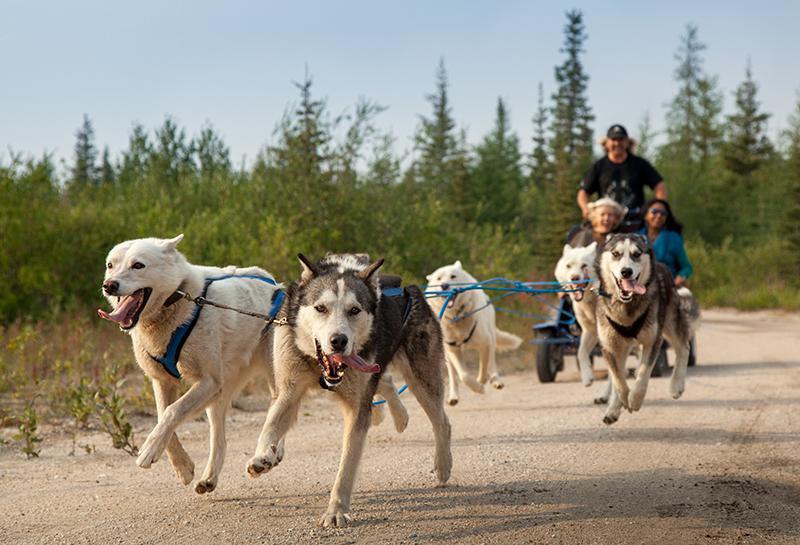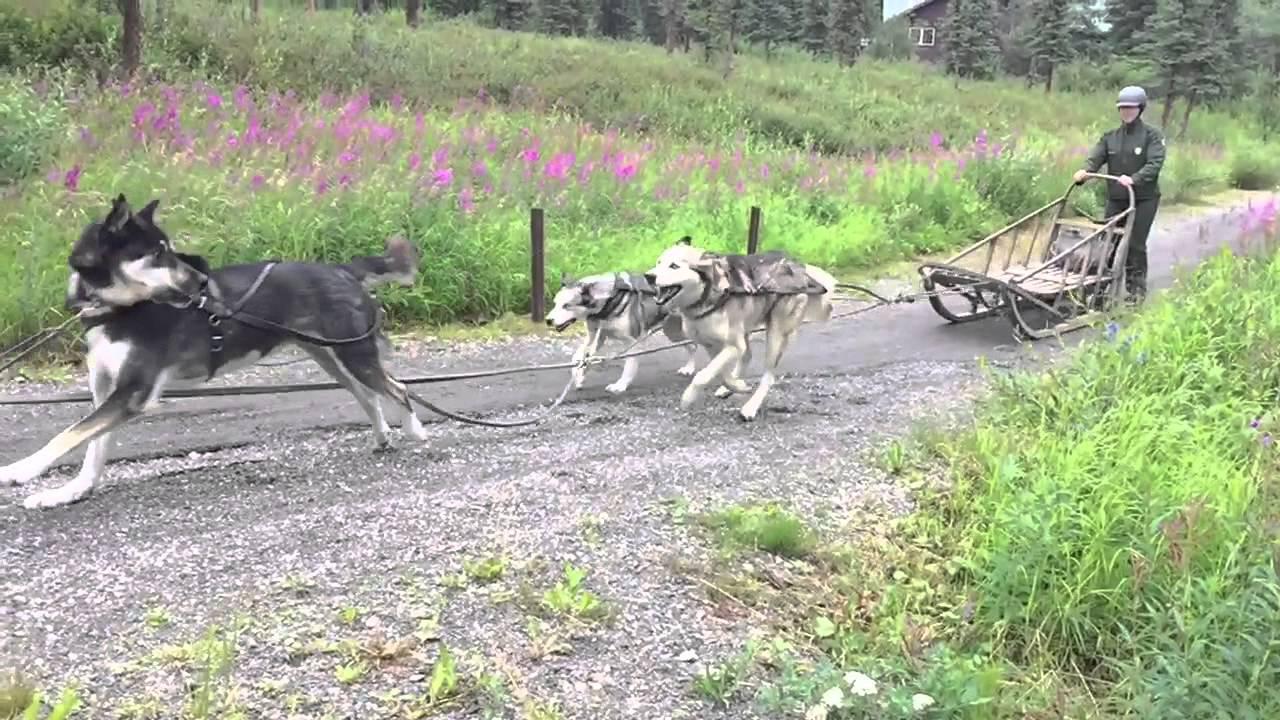The first image is the image on the left, the second image is the image on the right. For the images displayed, is the sentence "One image shows a team of dogs pulling a brown sled down an unpaved path, and the other image shows a team of dogs pulling a wheeled cart with passengers along a dirt road." factually correct? Answer yes or no. Yes. 